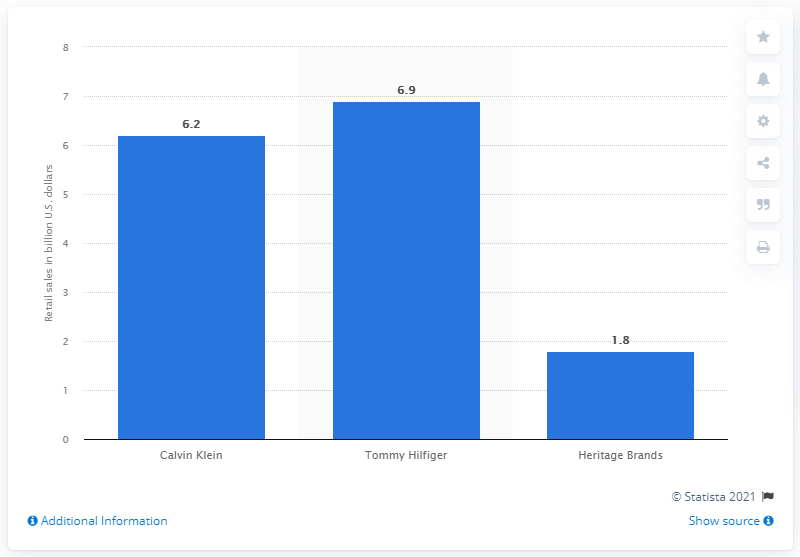Highlight a few significant elements in this photo. In 2020, Calvin Klein's retail sales in the U.S. reached $6.2 billion. According to the retail sales in 2020, Calvin Klein was the brand that generated approximately 6.2 billion U.S. dollars in sales. 